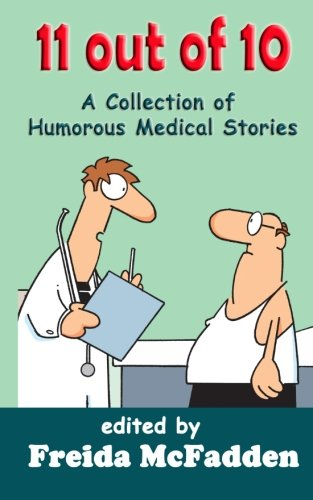What emotions do the characters on the cover convey? The characters on the cover portray a sense of casual professionalism mixed with a touch of comedic confusion. One character looks earnest and perhaps a bit bemused while talking, which injects a humorous element typical for a collection of funny medical stories. 